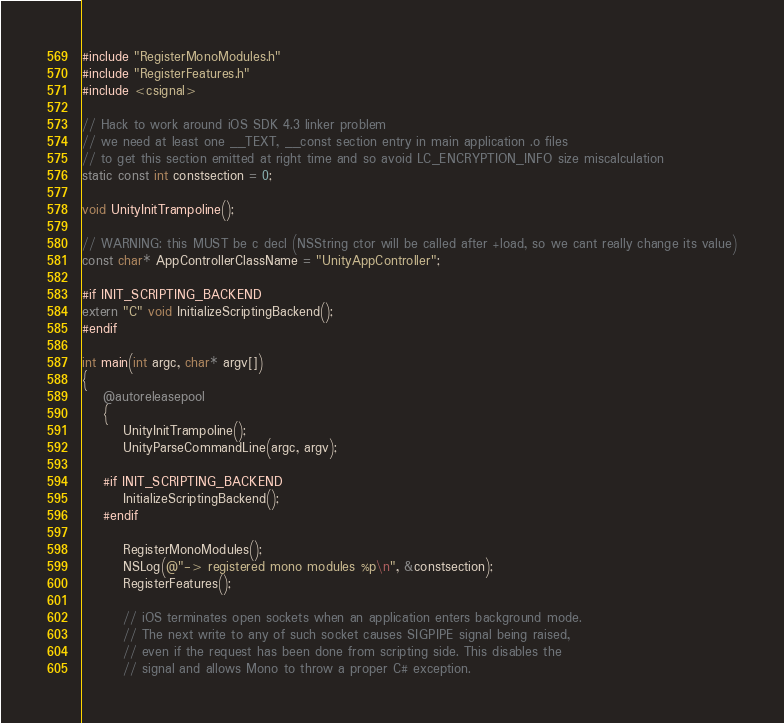Convert code to text. <code><loc_0><loc_0><loc_500><loc_500><_ObjectiveC_>#include "RegisterMonoModules.h"
#include "RegisterFeatures.h"
#include <csignal>

// Hack to work around iOS SDK 4.3 linker problem
// we need at least one __TEXT, __const section entry in main application .o files
// to get this section emitted at right time and so avoid LC_ENCRYPTION_INFO size miscalculation
static const int constsection = 0;

void UnityInitTrampoline();

// WARNING: this MUST be c decl (NSString ctor will be called after +load, so we cant really change its value)
const char* AppControllerClassName = "UnityAppController";

#if INIT_SCRIPTING_BACKEND
extern "C" void InitializeScriptingBackend();
#endif

int main(int argc, char* argv[])
{
	@autoreleasepool
	{
		UnityInitTrampoline();
		UnityParseCommandLine(argc, argv);

	#if INIT_SCRIPTING_BACKEND
		InitializeScriptingBackend();
	#endif

		RegisterMonoModules();
		NSLog(@"-> registered mono modules %p\n", &constsection);
		RegisterFeatures();

		// iOS terminates open sockets when an application enters background mode.
		// The next write to any of such socket causes SIGPIPE signal being raised,
		// even if the request has been done from scripting side. This disables the
		// signal and allows Mono to throw a proper C# exception.</code> 